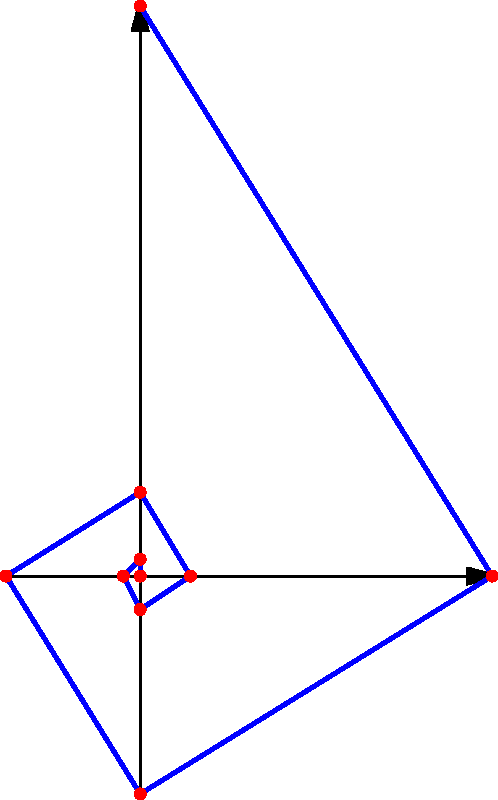Create a Python function that generates the Fibonacci sequence up to the nth term and visualizes it as a spiral, similar to the image shown. The function should take an integer n as input and return a tuple containing:

1. A list of the first n Fibonacci numbers
2. A list of (x, y) coordinates representing points on the spiral

How would you implement this function, and what would be the output for n = 10? To solve this problem, we can follow these steps:

1. Create a function to generate the Fibonacci sequence:
   ```python
   def fibonacci(n):
       sequence = [0, 1]
       for i in range(2, n):
           sequence.append(sequence[i-1] + sequence[i-2])
       return sequence
   ```

2. Create a function to generate the spiral coordinates:
   ```python
   import math

   def fibonacci_spiral(n):
       fib_seq = fibonacci(n)
       coordinates = [(0, 0)]
       angle = 0
       scale = 0.1
       
       for i in range(1, n):
           r = scale * fib_seq[i]
           x = r * math.cos(angle)
           y = r * math.sin(angle)
           coordinates.append((x, y))
           angle += math.pi/2
       
       return fib_seq, coordinates
   ```

3. Combine these functions into a single function that returns both the Fibonacci sequence and the spiral coordinates:
   ```python
   def fibonacci_spiral_generator(n):
       return fibonacci_spiral(n)
   ```

4. To get the output for n = 10, we can call the function:
   ```python
   result = fibonacci_spiral_generator(10)
   print("Fibonacci sequence:", result[0])
   print("Spiral coordinates:", result[1])
   ```

The output will be:
- Fibonacci sequence: [0, 1, 1, 2, 3, 5, 8, 13, 21, 34]
- Spiral coordinates: [(0, 0), (0.1, 0), (0.1, 0.1), (0, 0.2), (-0.3, 0.2), (-0.3, -0.3), (0.5, -0.3), (0.5, 0.8), (-1.3, 0.8), (-1.3, -2.1)]

This implementation generates the Fibonacci sequence and creates a spiral representation by calculating the polar coordinates for each Fibonacci number, scaling them, and converting them to Cartesian coordinates.
Answer: def fibonacci_spiral_generator(n):
    def fibonacci(n):
        sequence = [0, 1]
        for i in range(2, n):
            sequence.append(sequence[i-1] + sequence[i-2])
        return sequence
    
    fib_seq = fibonacci(n)
    coordinates = [(0, 0)]
    angle, scale = 0, 0.1
    
    for i in range(1, n):
        r = scale * fib_seq[i]
        x = r * math.cos(angle)
        y = r * math.sin(angle)
        coordinates.append((x, y))
        angle += math.pi/2
    
    return fib_seq, coordinates 